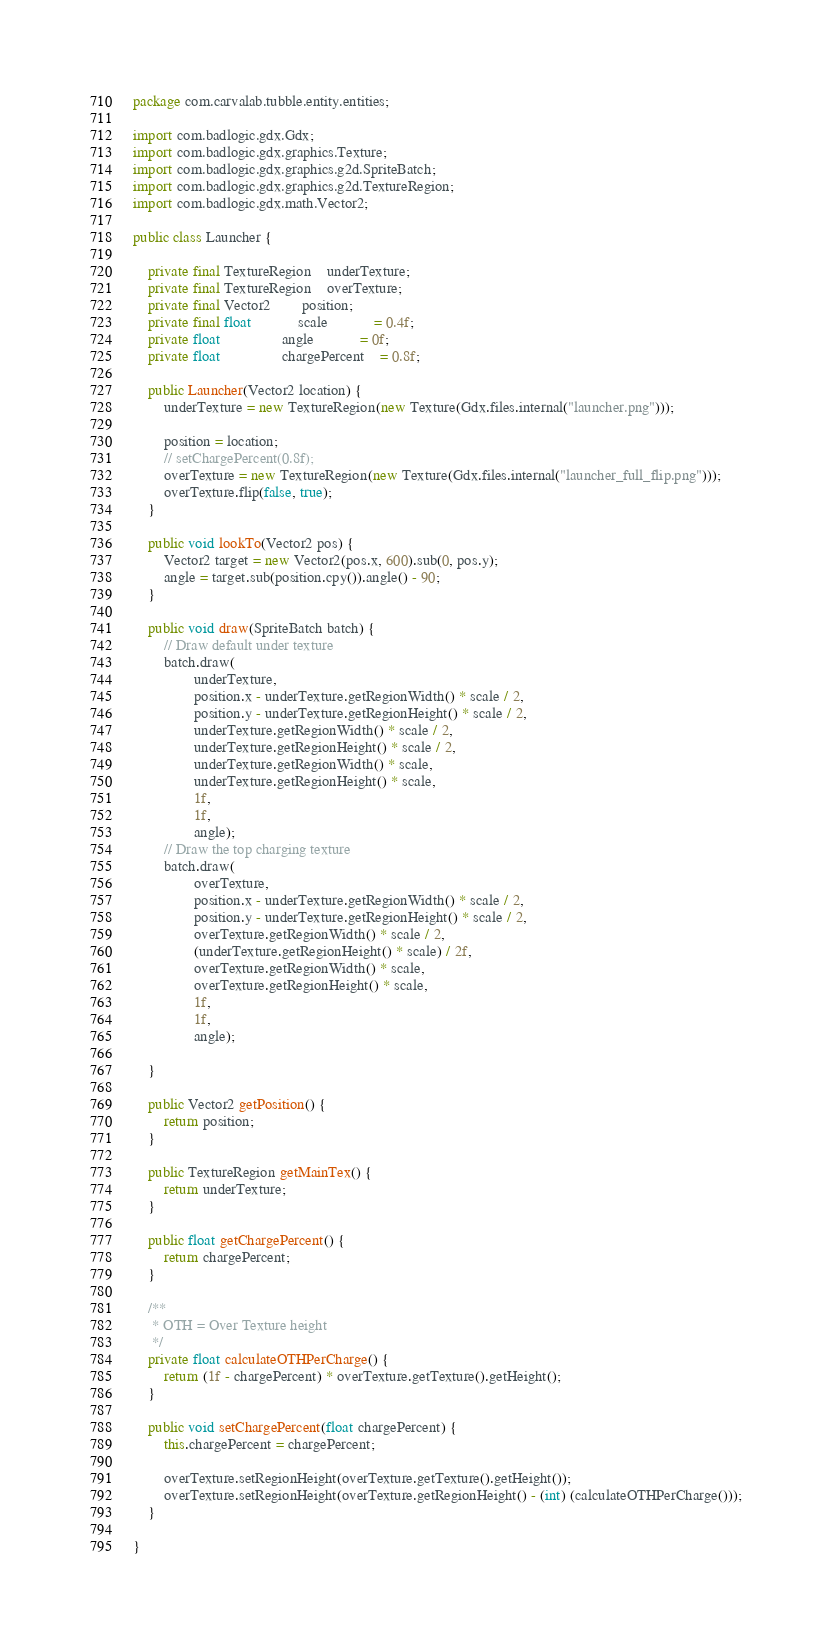Convert code to text. <code><loc_0><loc_0><loc_500><loc_500><_Java_>package com.carvalab.tubble.entity.entities;

import com.badlogic.gdx.Gdx;
import com.badlogic.gdx.graphics.Texture;
import com.badlogic.gdx.graphics.g2d.SpriteBatch;
import com.badlogic.gdx.graphics.g2d.TextureRegion;
import com.badlogic.gdx.math.Vector2;

public class Launcher {

	private final TextureRegion	underTexture;
	private final TextureRegion	overTexture;
	private final Vector2		position;
	private final float			scale			= 0.4f;
	private float				angle			= 0f;
	private float				chargePercent	= 0.8f;

	public Launcher(Vector2 location) {
		underTexture = new TextureRegion(new Texture(Gdx.files.internal("launcher.png")));

		position = location;
		// setChargePercent(0.8f);
		overTexture = new TextureRegion(new Texture(Gdx.files.internal("launcher_full_flip.png")));
		overTexture.flip(false, true);
	}

	public void lookTo(Vector2 pos) {
		Vector2 target = new Vector2(pos.x, 600).sub(0, pos.y);
		angle = target.sub(position.cpy()).angle() - 90;
	}

	public void draw(SpriteBatch batch) {
		// Draw default under texture
		batch.draw(
				underTexture,
				position.x - underTexture.getRegionWidth() * scale / 2,
				position.y - underTexture.getRegionHeight() * scale / 2,
				underTexture.getRegionWidth() * scale / 2,
				underTexture.getRegionHeight() * scale / 2,
				underTexture.getRegionWidth() * scale,
				underTexture.getRegionHeight() * scale,
				1f,
				1f,
				angle);
		// Draw the top charging texture
		batch.draw(
				overTexture,
				position.x - underTexture.getRegionWidth() * scale / 2,
				position.y - underTexture.getRegionHeight() * scale / 2,
				overTexture.getRegionWidth() * scale / 2,
				(underTexture.getRegionHeight() * scale) / 2f,
				overTexture.getRegionWidth() * scale,
				overTexture.getRegionHeight() * scale,
				1f,
				1f,
				angle);

	}

	public Vector2 getPosition() {
		return position;
	}

	public TextureRegion getMainTex() {
		return underTexture;
	}

	public float getChargePercent() {
		return chargePercent;
	}

	/**
	 * OTH = Over Texture height
	 */
	private float calculateOTHPerCharge() {
		return (1f - chargePercent) * overTexture.getTexture().getHeight();
	}

	public void setChargePercent(float chargePercent) {
		this.chargePercent = chargePercent;

		overTexture.setRegionHeight(overTexture.getTexture().getHeight());
		overTexture.setRegionHeight(overTexture.getRegionHeight() - (int) (calculateOTHPerCharge()));
	}

}
</code> 